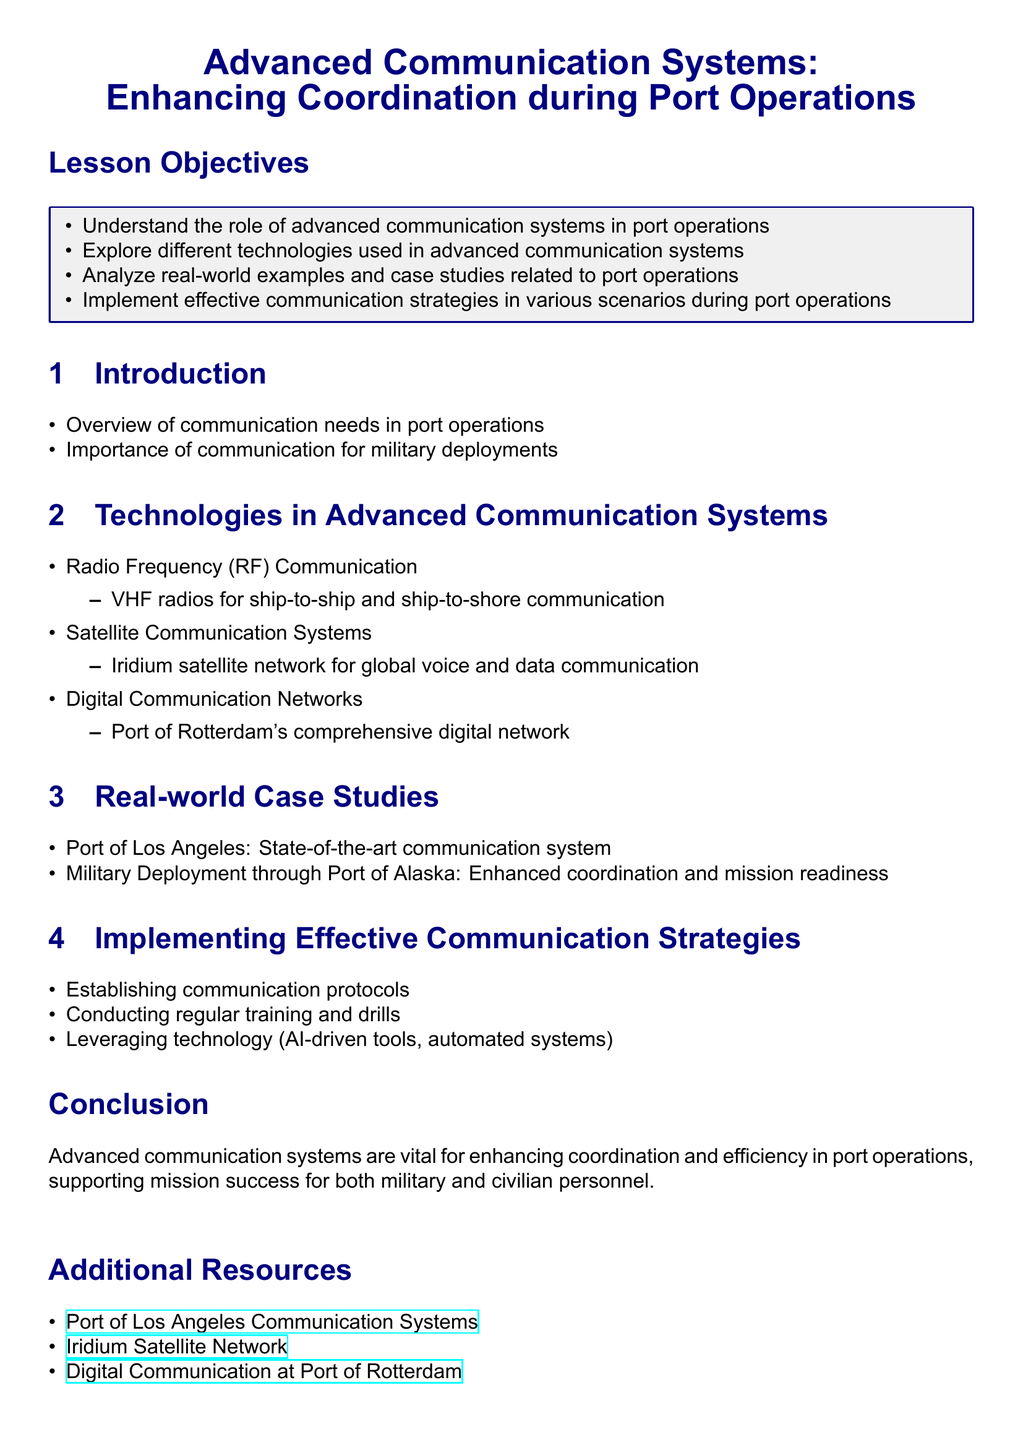What are the lesson objectives? The lesson objectives are outlined in the document and include understanding, exploring technologies, analyzing examples, and implementing strategies.
Answer: Understand the role of advanced communication systems in port operations, Explore different technologies used in advanced communication systems, Analyze real-world examples and case studies related to port operations, Implement effective communication strategies in various scenarios during port operations What technology is used for ship-to-ship communication? The document specifies that VHF radios are used for this purpose as part of Radio Frequency Communication.
Answer: VHF radios Which satellite network is mentioned for global communication? The document specifically mentions the Iridium satellite network for voice and data communication.
Answer: Iridium satellite network What case study is mentioned related to military deployment? The document includes the Military Deployment through Port of Alaska as a case study to enhance coordination and mission readiness.
Answer: Military Deployment through Port of Alaska What is emphasized as vital in the conclusion? The conclusion highlights the importance of advanced communication systems for enhancing coordination and efficiency in port operations.
Answer: Advanced communication systems What is one of the effective communication strategies mentioned? The document includes establishing communication protocols as one of the strategies to implement.
Answer: Establishing communication protocols 